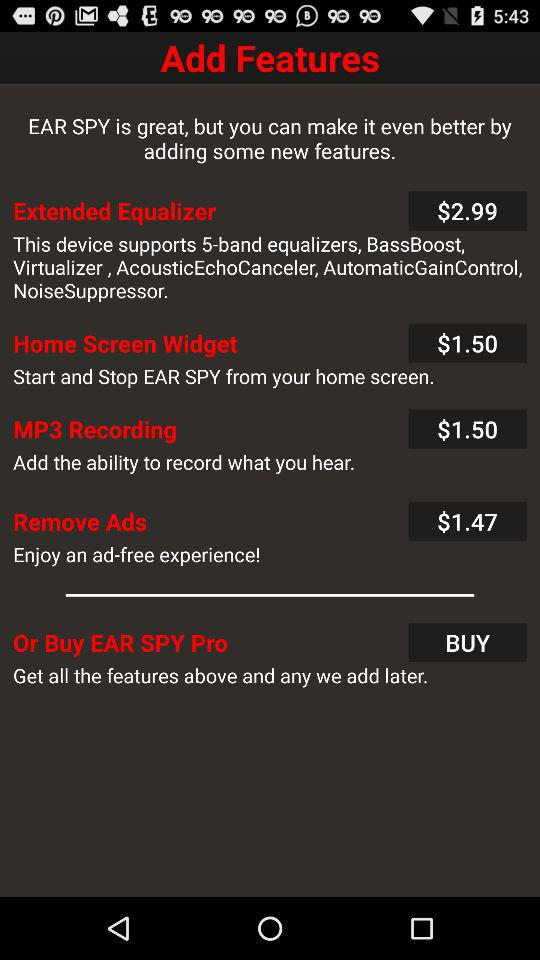What is the price of the "MP3 Recording" feature? The price of the "MP3 Recording" feature is $1.50. 